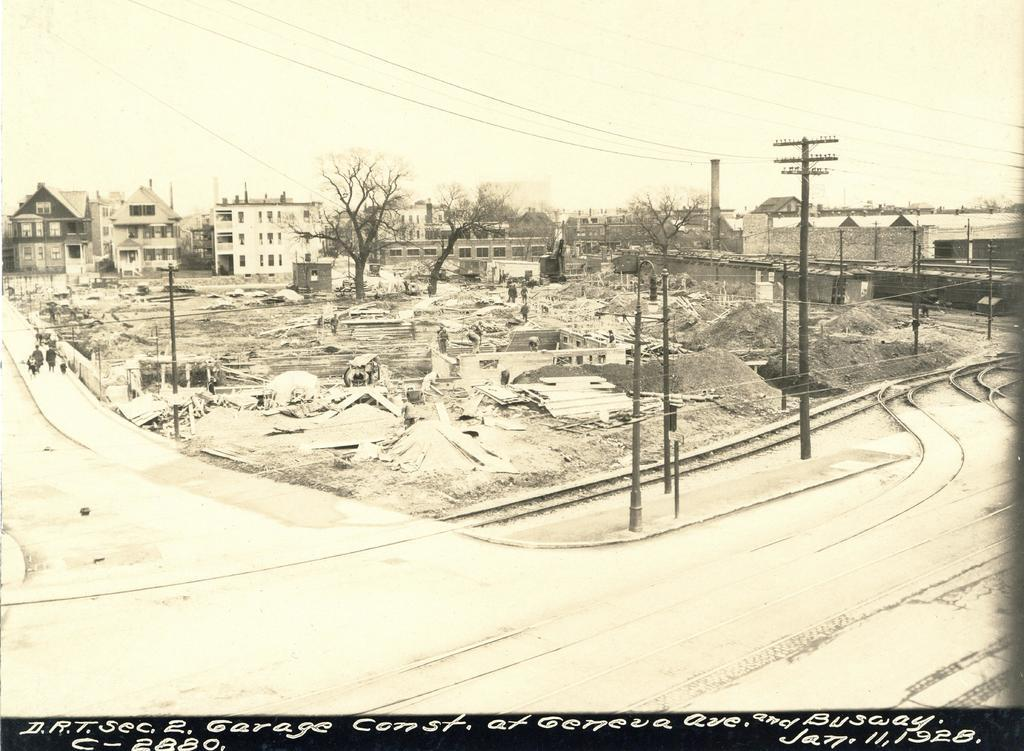What type of drawing is in the image? The image contains a pencil sketch drawing. What is the subject of the drawing? The drawing depicts an area with railway tracks. Are there any other elements in the drawing besides railway tracks? Yes, the drawing includes roads, people walking, houses, buildings with windows and doors, trees, and sheds. How many streetlights are present in the drawing? There is no mention of streetlights in the provided facts, so we cannot determine the number of streetlights in the drawing. 